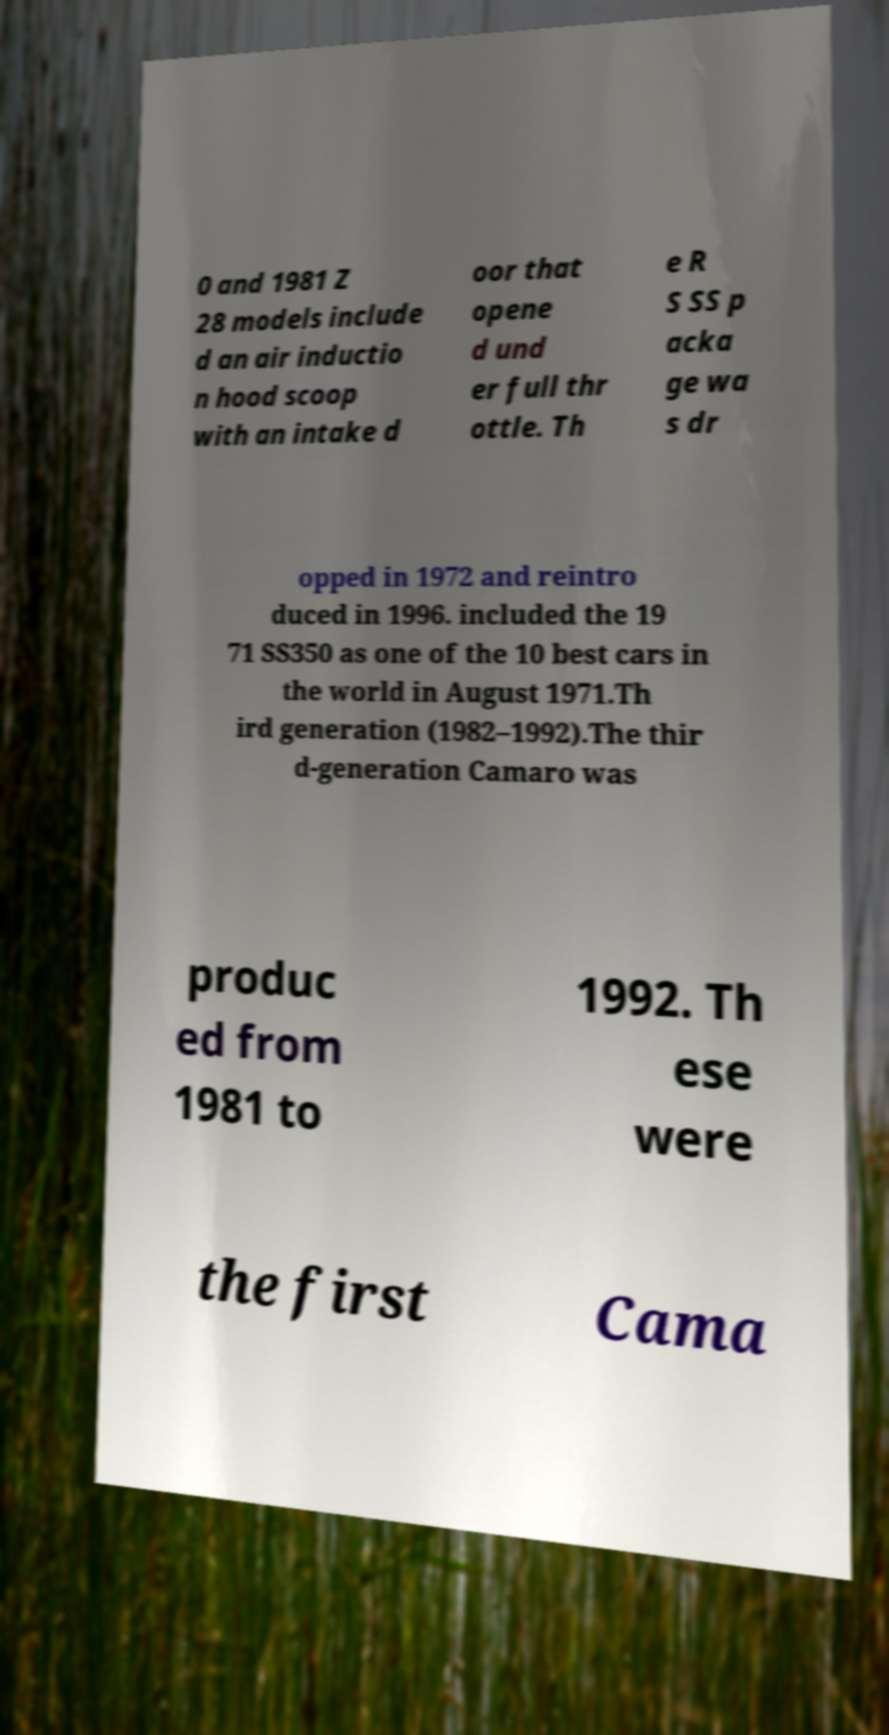I need the written content from this picture converted into text. Can you do that? 0 and 1981 Z 28 models include d an air inductio n hood scoop with an intake d oor that opene d und er full thr ottle. Th e R S SS p acka ge wa s dr opped in 1972 and reintro duced in 1996. included the 19 71 SS350 as one of the 10 best cars in the world in August 1971.Th ird generation (1982–1992).The thir d-generation Camaro was produc ed from 1981 to 1992. Th ese were the first Cama 